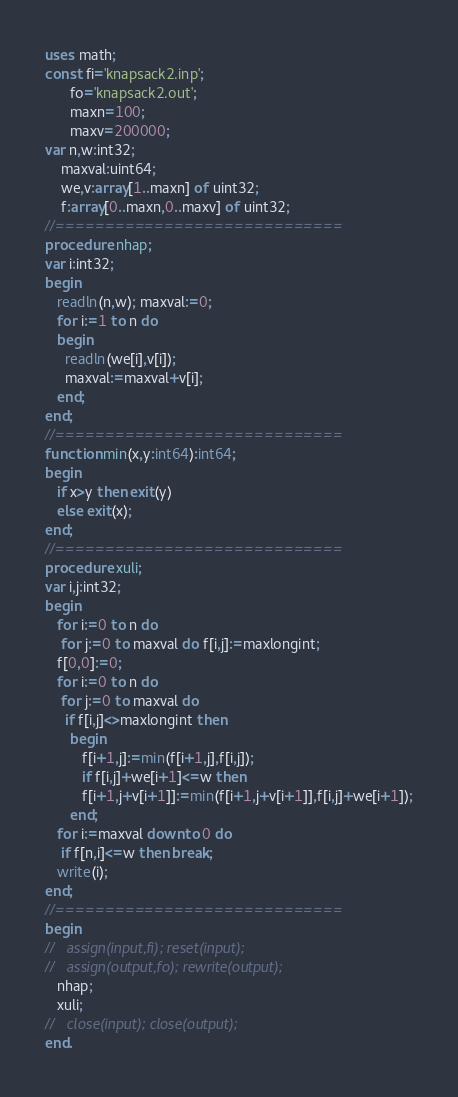<code> <loc_0><loc_0><loc_500><loc_500><_Pascal_>uses math;
const fi='knapsack2.inp';
      fo='knapsack2.out';
      maxn=100;
      maxv=200000;
var n,w:int32;
    maxval:uint64;
    we,v:array[1..maxn] of uint32;
    f:array[0..maxn,0..maxv] of uint32;
//=============================
procedure nhap;
var i:int32;
begin
   readln(n,w); maxval:=0;
   for i:=1 to n do
   begin
     readln(we[i],v[i]);
     maxval:=maxval+v[i];
   end;
end;
//=============================
function min(x,y:int64):int64;
begin
   if x>y then exit(y)
   else exit(x);
end;
//=============================
procedure xuli;
var i,j:int32;
begin
   for i:=0 to n do
    for j:=0 to maxval do f[i,j]:=maxlongint;
   f[0,0]:=0;
   for i:=0 to n do
    for j:=0 to maxval do
     if f[i,j]<>maxlongint then
      begin
         f[i+1,j]:=min(f[i+1,j],f[i,j]);
         if f[i,j]+we[i+1]<=w then
         f[i+1,j+v[i+1]]:=min(f[i+1,j+v[i+1]],f[i,j]+we[i+1]);
      end;
   for i:=maxval downto 0 do
    if f[n,i]<=w then break;
   write(i);
end;
//=============================
begin
//   assign(input,fi); reset(input);
//   assign(output,fo); rewrite(output);
   nhap;
   xuli;
//   close(input); close(output);
end.
</code> 